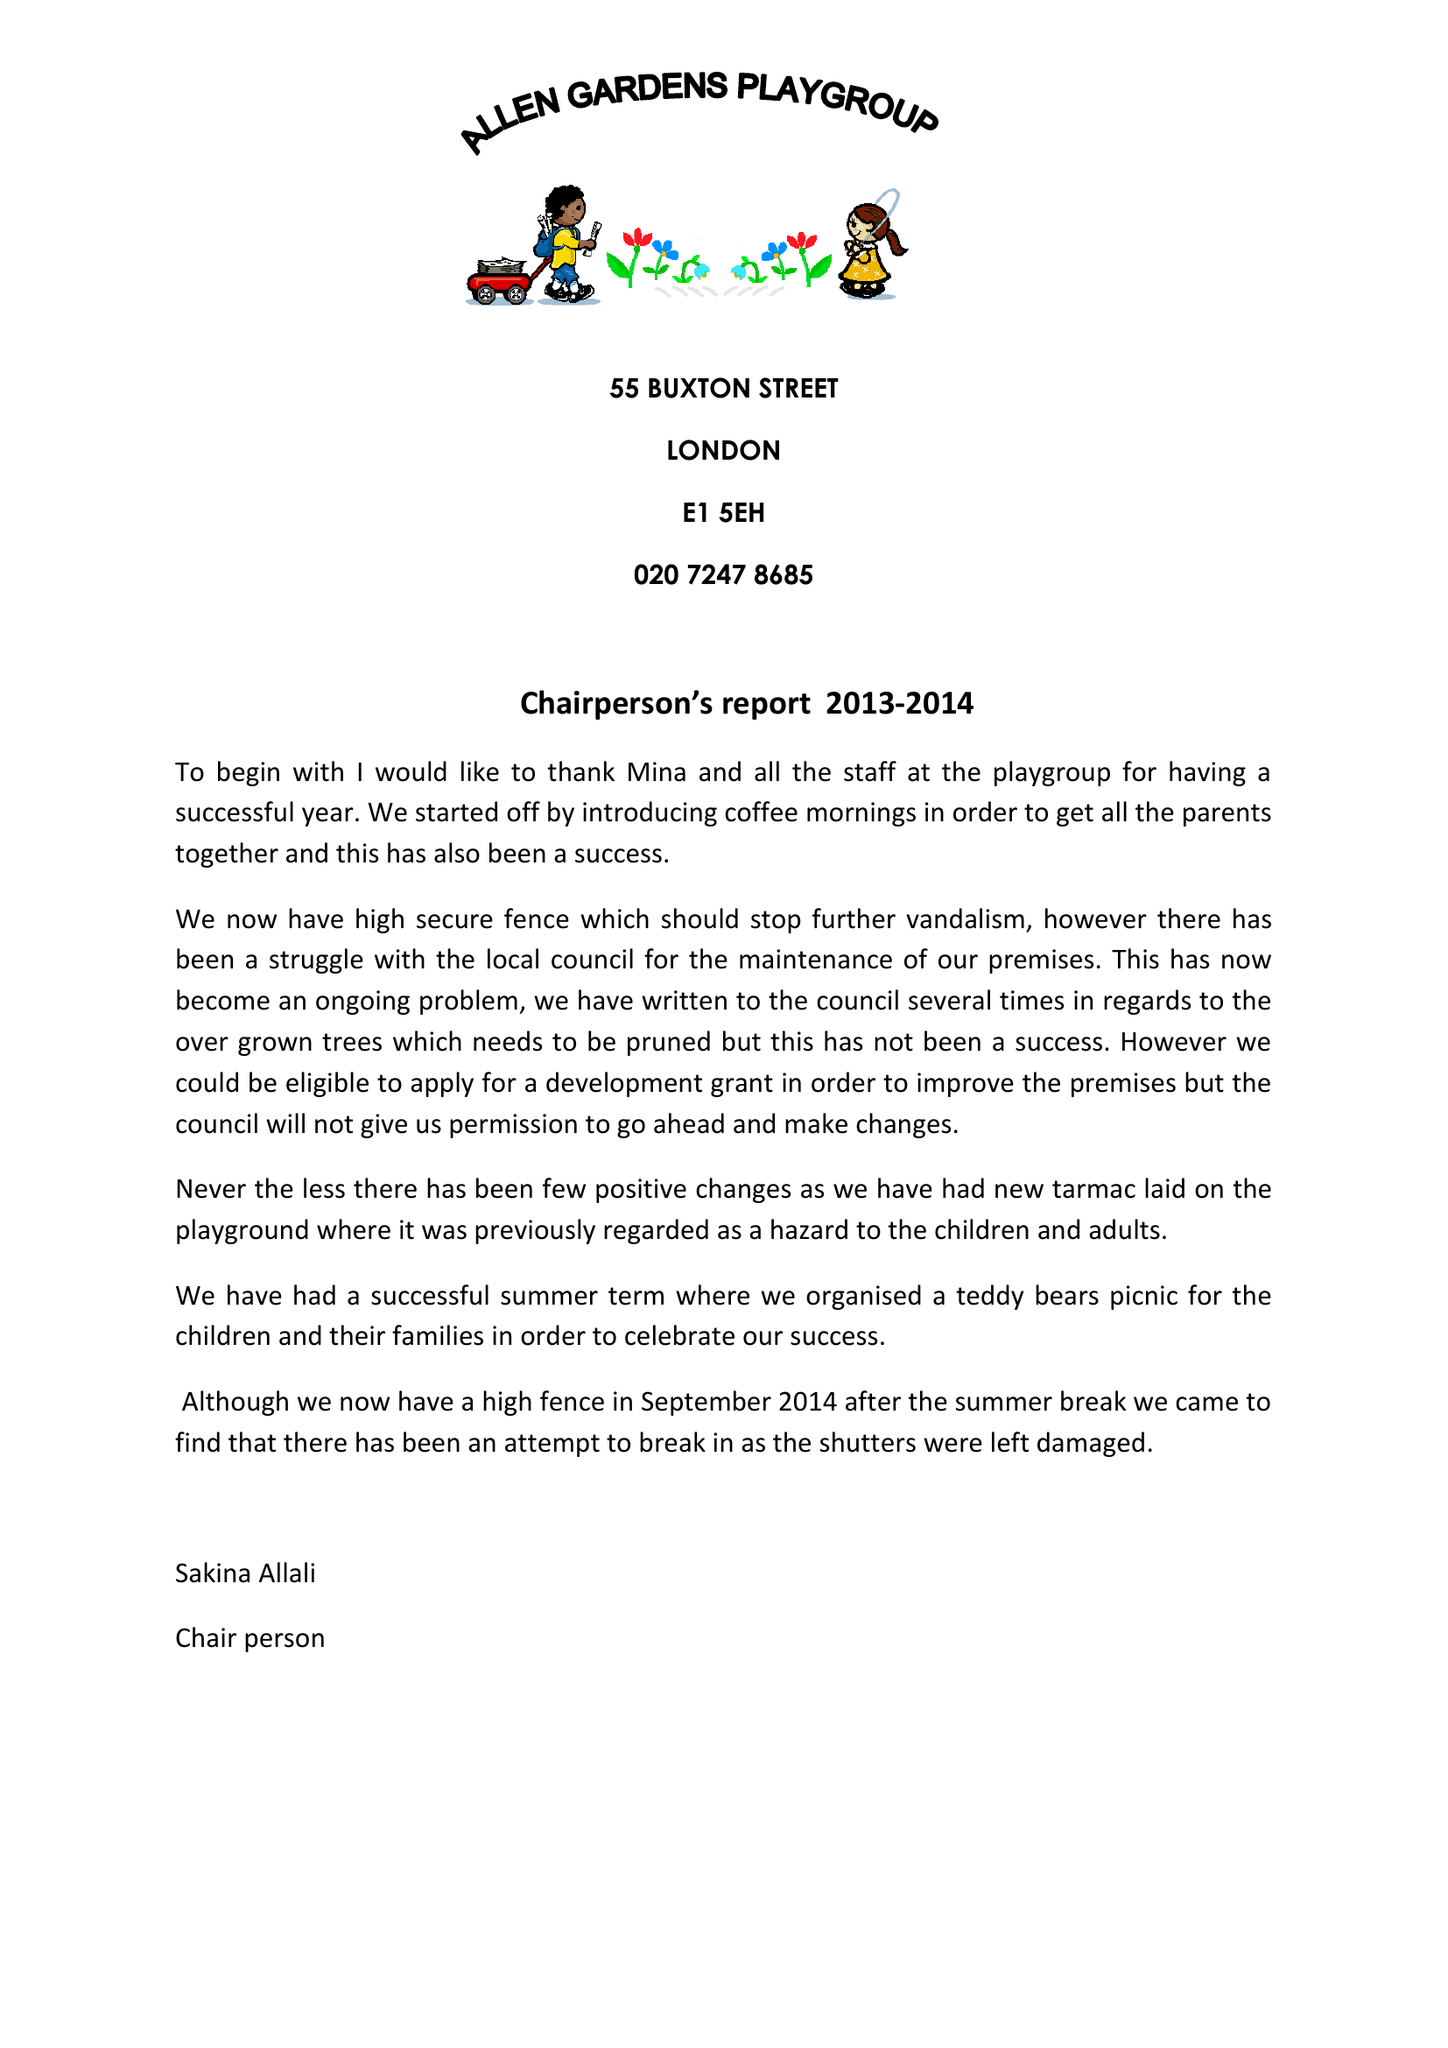What is the value for the address__street_line?
Answer the question using a single word or phrase. 55 BUXTON STREET 